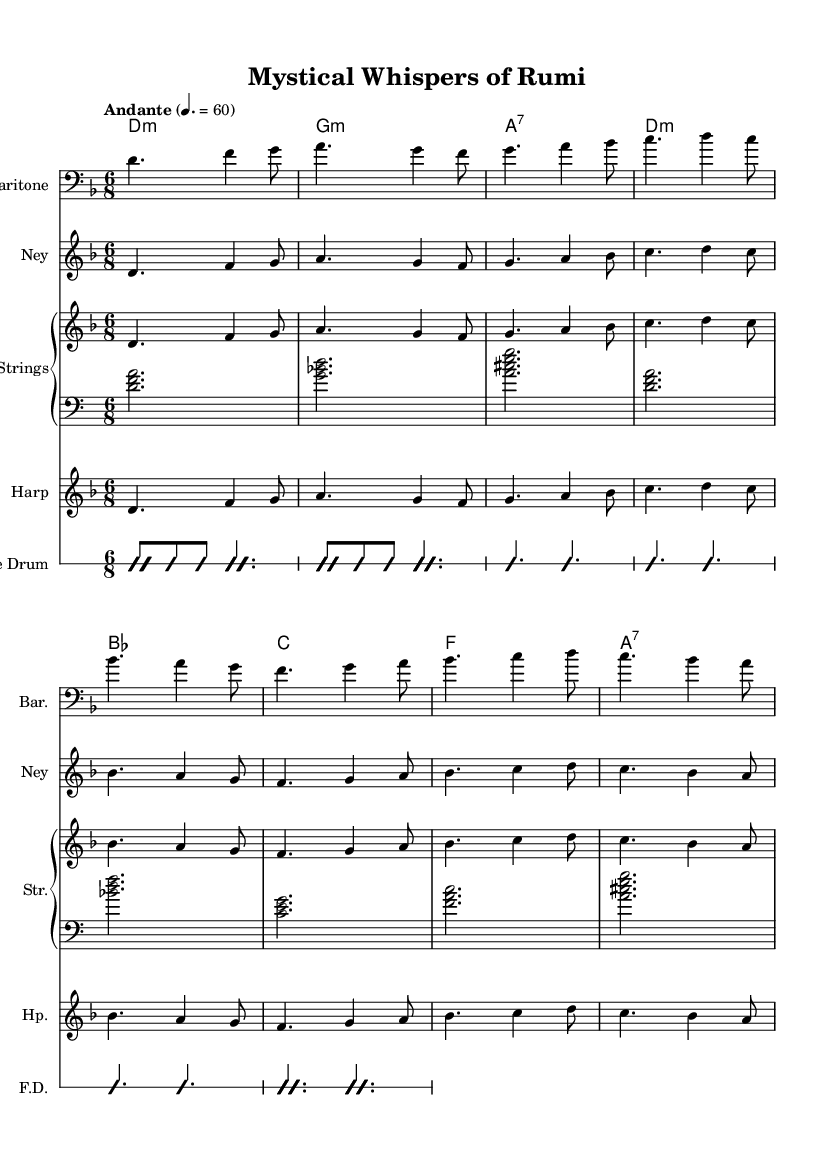What is the key signature of this music? The key signature indicated in the music score is D minor, which has one flat (B flat) in its key signature.
Answer: D minor What is the time signature of the piece? The time signature is shown as 6/8, which means there are six eighth-note beats per measure.
Answer: 6/8 What is the tempo marking for this music? The tempo marking states "Andante" with a metronome marking of 60 beats per minute. "Andante" suggests a moderately slow tempo.
Answer: Andante How many measures are there in the melody? By counting the measures in the melody line, it can be seen that there are eight measures.
Answer: 8 What types of instruments are used in this arrangement? The arrangement includes a Baritone, Ney, Strings (Piano), and Harp, among others, as indicated in the score.
Answer: Baritone, Ney, Strings, Harp What chord is used in the second measure? In the second measure of the harmonies portion, the chord is G minor, as it is labeled in the chord names below the staff.
Answer: G minor What musical genre does this piece exemplify? This piece falls under World Music, particularly reflecting the style of Persian Sufi chants with modern orchestral elements.
Answer: World Music, Persian Sufi chants 